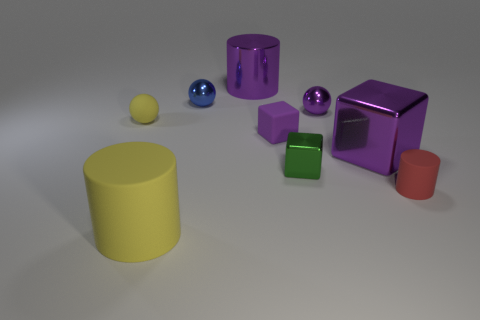There is another block that is the same size as the matte cube; what is its color?
Provide a succinct answer. Green. How big is the yellow object that is in front of the big purple metal cube?
Keep it short and to the point. Large. There is a small metallic object on the right side of the green thing; are there any rubber cylinders in front of it?
Provide a short and direct response. Yes. Does the blue object that is on the left side of the big purple cube have the same material as the purple cylinder?
Offer a terse response. Yes. How many things are both to the right of the purple metal ball and to the left of the green thing?
Provide a succinct answer. 0. How many large green cubes are made of the same material as the red object?
Your answer should be compact. 0. There is a small cylinder that is the same material as the large yellow object; what color is it?
Your response must be concise. Red. Is the number of large blue spheres less than the number of large cylinders?
Make the answer very short. Yes. What material is the large purple thing that is to the right of the green shiny block that is on the right side of the big cylinder on the right side of the tiny blue sphere?
Provide a short and direct response. Metal. What is the material of the large purple cylinder?
Offer a very short reply. Metal. 